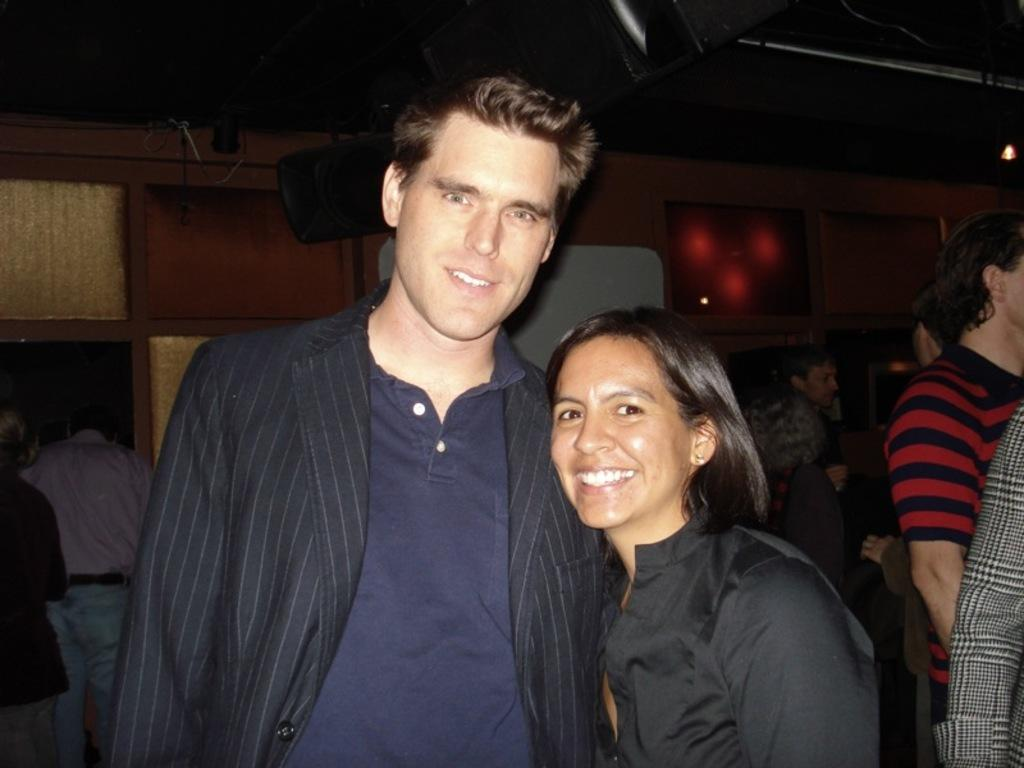How many people are present in the image? There are two people, a man and a woman, present in the image. What are the man and woman doing in the image? Both the man and woman are standing and smiling in the image. What can be seen in the background of the image? There is a wall and other objects visible in the background of the image. Can you describe the group of people in the image? The group of people in the image consists of the man and woman who are standing and smiling. What type of furniture is being magically transported in the image? There is no furniture or magic present in the image; it features a man and a woman standing and smiling with a group of people in the background. 